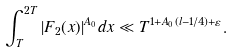Convert formula to latex. <formula><loc_0><loc_0><loc_500><loc_500>\int _ { T } ^ { 2 T } | F _ { 2 } ( x ) | ^ { A _ { 0 } } d x \ll T ^ { 1 + A _ { 0 } ( l - 1 / 4 ) + \varepsilon } .</formula> 